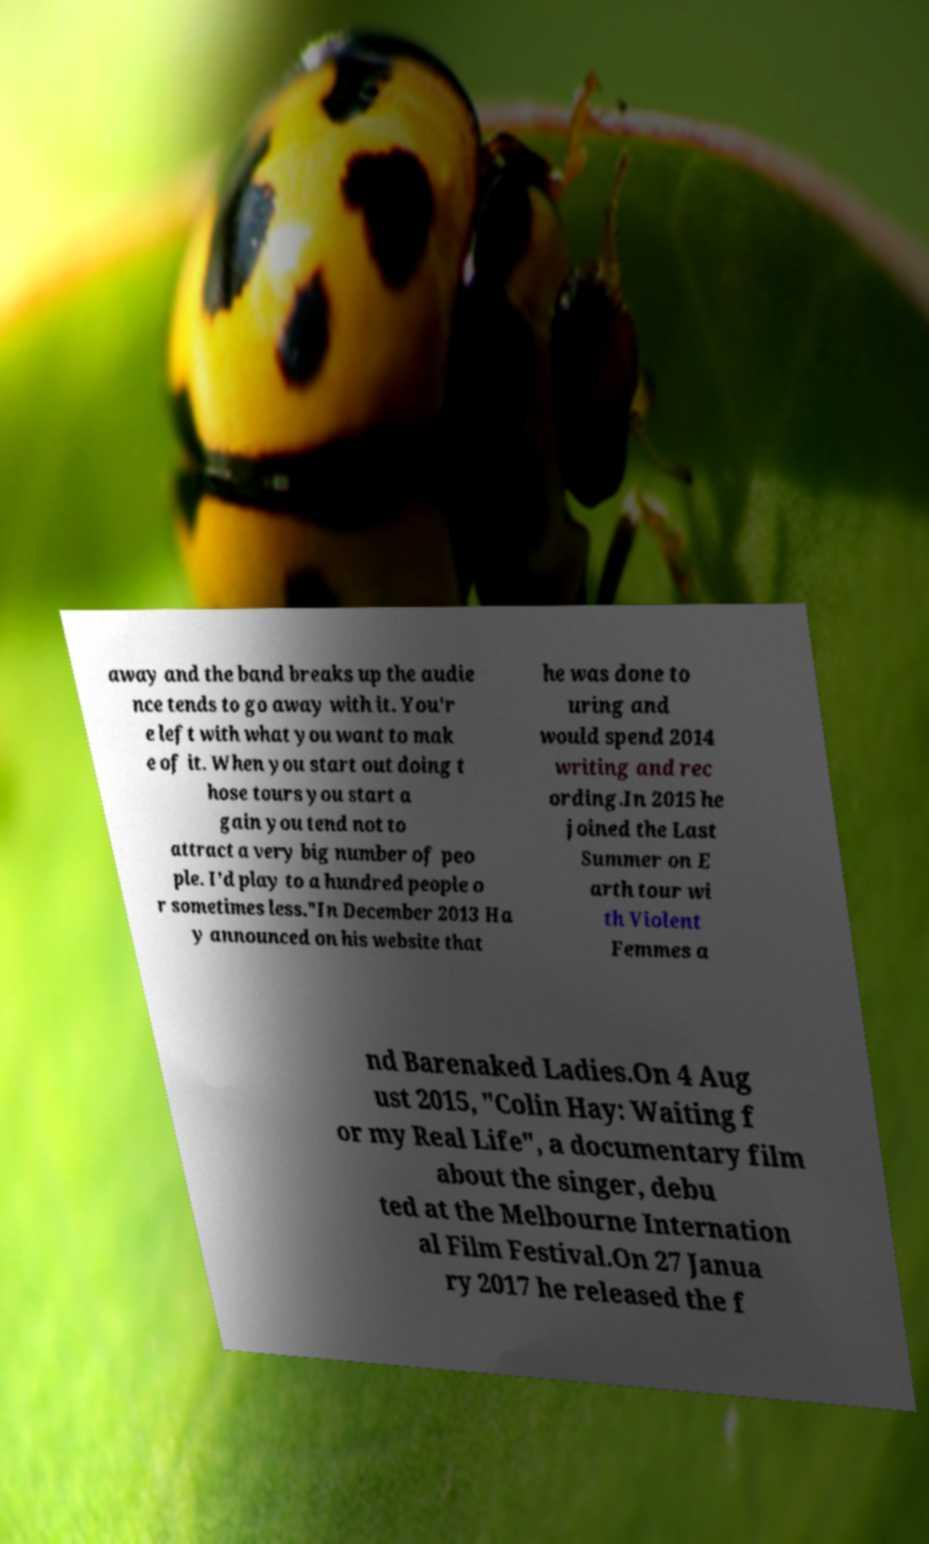Please identify and transcribe the text found in this image. away and the band breaks up the audie nce tends to go away with it. You'r e left with what you want to mak e of it. When you start out doing t hose tours you start a gain you tend not to attract a very big number of peo ple. I'd play to a hundred people o r sometimes less."In December 2013 Ha y announced on his website that he was done to uring and would spend 2014 writing and rec ording.In 2015 he joined the Last Summer on E arth tour wi th Violent Femmes a nd Barenaked Ladies.On 4 Aug ust 2015, "Colin Hay: Waiting f or my Real Life", a documentary film about the singer, debu ted at the Melbourne Internation al Film Festival.On 27 Janua ry 2017 he released the f 